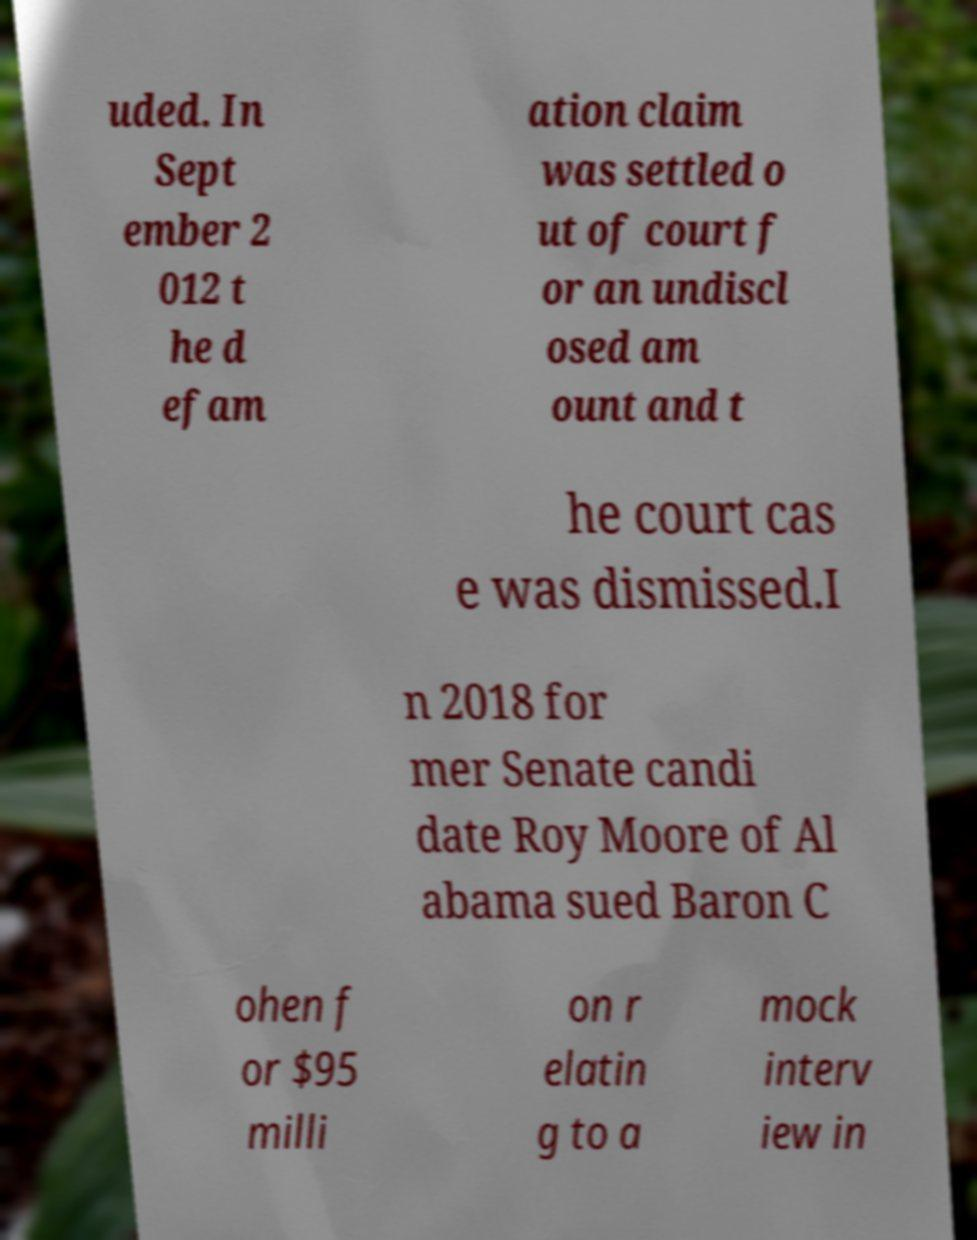Can you accurately transcribe the text from the provided image for me? uded. In Sept ember 2 012 t he d efam ation claim was settled o ut of court f or an undiscl osed am ount and t he court cas e was dismissed.I n 2018 for mer Senate candi date Roy Moore of Al abama sued Baron C ohen f or $95 milli on r elatin g to a mock interv iew in 